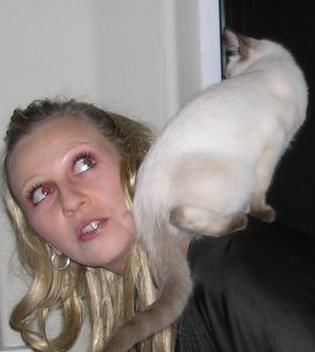Describe the objects in this image and their specific colors. I can see people in darkgray, black, and gray tones and cat in darkgray, lightgray, and gray tones in this image. 